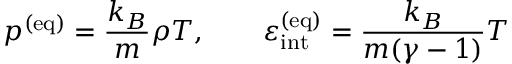Convert formula to latex. <formula><loc_0><loc_0><loc_500><loc_500>p ^ { ( e q ) } = \frac { k _ { B } } { m } \rho T , \quad \varepsilon _ { i n t } ^ { ( e q ) } = \frac { k _ { B } } { m ( \gamma - 1 ) } T</formula> 